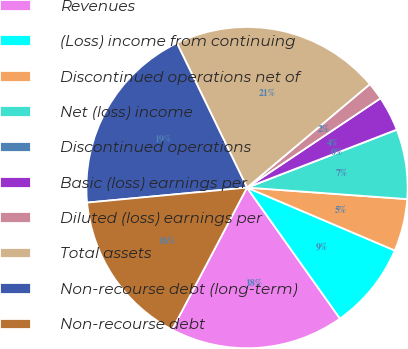Convert chart. <chart><loc_0><loc_0><loc_500><loc_500><pie_chart><fcel>Revenues<fcel>(Loss) income from continuing<fcel>Discontinued operations net of<fcel>Net (loss) income<fcel>Discontinued operations<fcel>Basic (loss) earnings per<fcel>Diluted (loss) earnings per<fcel>Total assets<fcel>Non-recourse debt (long-term)<fcel>Non-recourse debt<nl><fcel>17.54%<fcel>8.77%<fcel>5.26%<fcel>7.02%<fcel>0.0%<fcel>3.51%<fcel>1.75%<fcel>21.05%<fcel>19.3%<fcel>15.79%<nl></chart> 